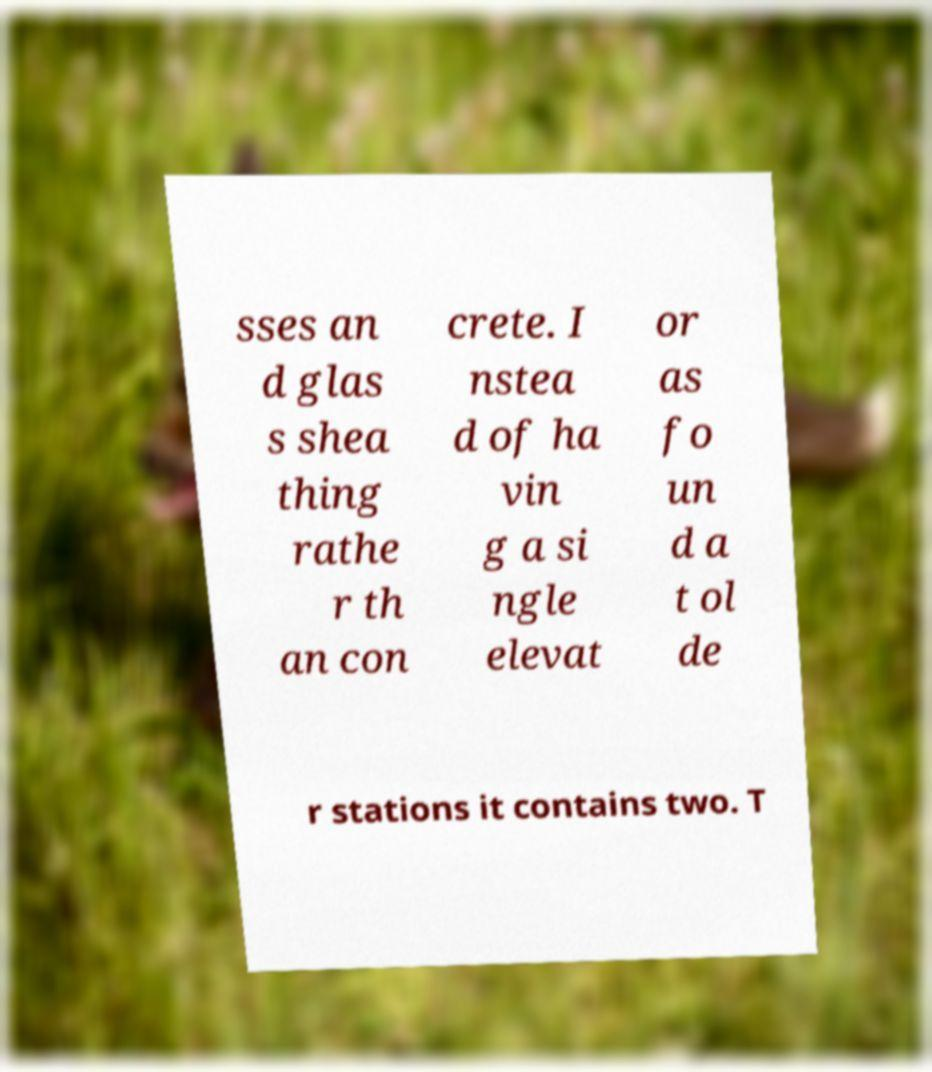There's text embedded in this image that I need extracted. Can you transcribe it verbatim? sses an d glas s shea thing rathe r th an con crete. I nstea d of ha vin g a si ngle elevat or as fo un d a t ol de r stations it contains two. T 